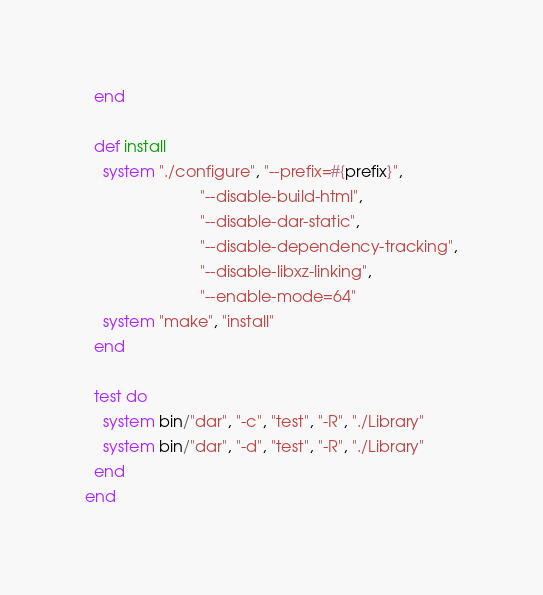Convert code to text. <code><loc_0><loc_0><loc_500><loc_500><_Ruby_>  end

  def install
    system "./configure", "--prefix=#{prefix}",
                          "--disable-build-html",
                          "--disable-dar-static",
                          "--disable-dependency-tracking",
                          "--disable-libxz-linking",
                          "--enable-mode=64"
    system "make", "install"
  end

  test do
    system bin/"dar", "-c", "test", "-R", "./Library"
    system bin/"dar", "-d", "test", "-R", "./Library"
  end
end
</code> 